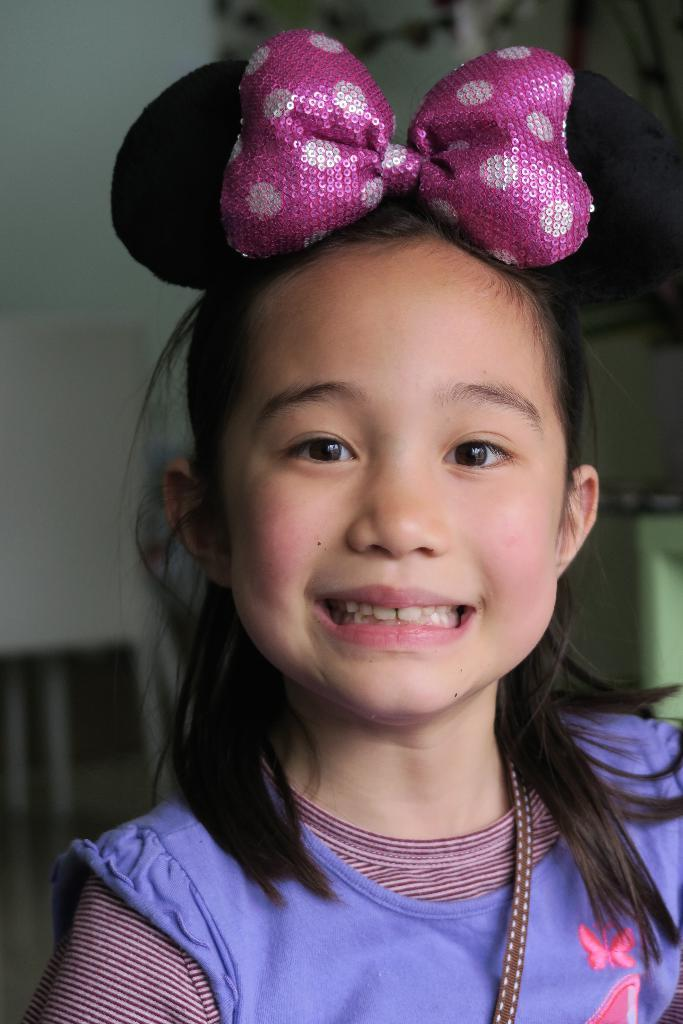Who is present in the image? There is a girl in the image. What is the girl's expression in the image? The girl is smiling in the image. What type of pie is the girl holding in the image? There is no pie present in the image; the girl is simply smiling. 